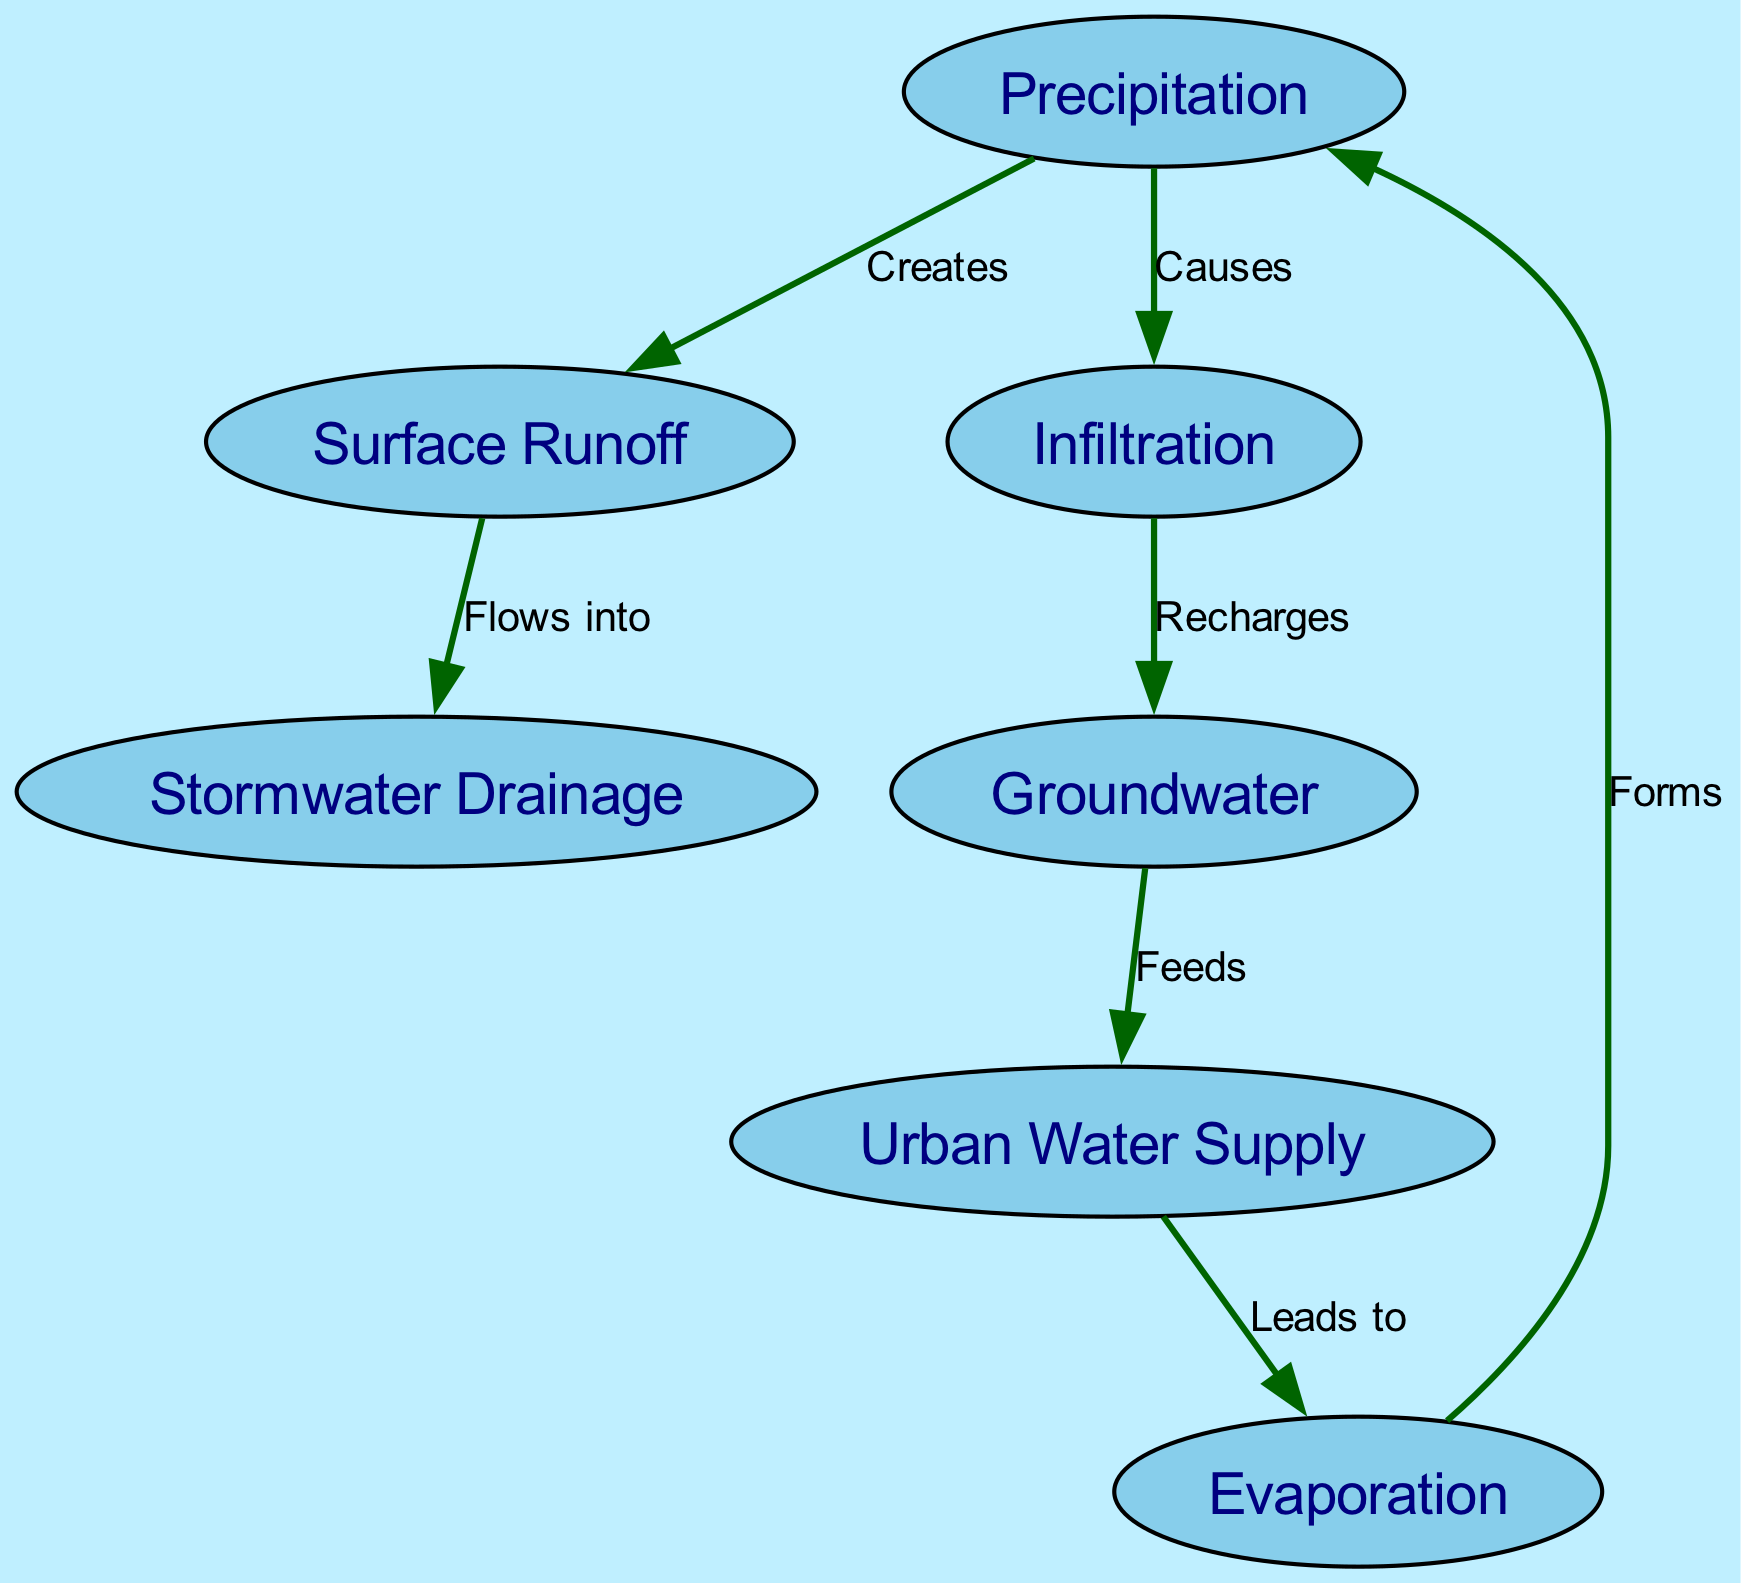What creates surface runoff? The diagram indicates that precipitation creates surface runoff, showing a direct relationship where precipitation leads to the formation of surface runoff.
Answer: Precipitation What flows into stormwater drainage? According to the diagram, surface runoff flows into stormwater drainage, which illustrates how water movement is directed from surface runoff to drainage systems.
Answer: Surface Runoff How many nodes are there in total? The diagram contains seven distinct nodes, each representing a component of the water cycle and its interaction with urban infrastructure.
Answer: Seven What recharges groundwater? The diagram illustrates that infiltration recharges groundwater, indicating that water absorption into the soil contributes to the groundwater supply.
Answer: Infiltration Which node feeds the urban water supply? The diagram shows that groundwater feeds the urban water supply, demonstrating the link between groundwater resources and the water needs of urban areas.
Answer: Groundwater What relationship exists between evaporation and precipitation? The diagram indicates that evaporation leads to precipitation, meaning that the process of water turning into vapor eventually contributes to rain or other forms of precipitation.
Answer: Leads to How does urban water supply relate to evaporation? The diagram explains that the urban water supply leads to evaporation, showing that water usage in urban areas influences the amount of water that returns to the atmosphere through evaporation.
Answer: Leads to What is the total number of edges in the diagram? The diagram contains six edges that represent the connections and relationships between the defined nodes, illustrating the flow within the water cycle.
Answer: Six What causes infiltration? The diagram states that precipitation causes infiltration, indicating how falling water contributes to the process of absorption into the ground.
Answer: Causes What forms precipitation? The diagram concludes that evaporation forms precipitation, highlighting the cyclical nature of water transitioning from vapor back to liquid in the form of precipitation.
Answer: Forms 